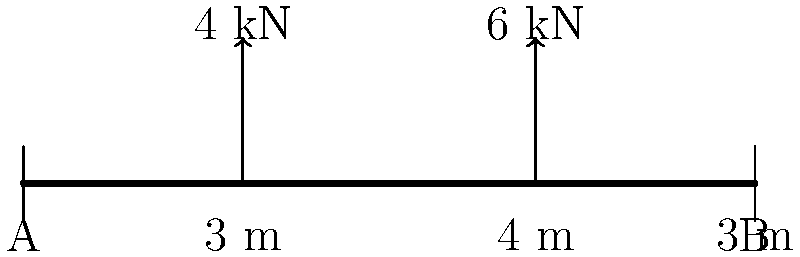As part of a community workshop on ancient structural engineering, you're discussing load distribution on simple beams. Consider a simply supported beam of length 10 m with two concentrated forces: a 4 kN force at 3 m from the left support and a 6 kN force at 7 m from the left support. Calculate the reaction force at support A. To solve this problem, we'll use the principles of static equilibrium. Here's a step-by-step approach:

1) First, let's define our variables:
   $R_A$ = Reaction force at support A
   $R_B$ = Reaction force at support B

2) We know that for a beam in equilibrium, the sum of all vertical forces must equal zero:
   $$\sum F_y = 0$$
   $$R_A + R_B - 4 \text{ kN} - 6 \text{ kN} = 0$$

3) We also know that the sum of moments about any point should be zero. Let's take moments about point A:
   $$\sum M_A = 0$$
   $$(4 \text{ kN} \times 3 \text{ m}) + (6 \text{ kN} \times 7 \text{ m}) - (R_B \times 10 \text{ m}) = 0$$
   $$12 + 42 - 10R_B = 0$$
   $$54 = 10R_B$$
   $$R_B = 5.4 \text{ kN}$$

4) Now that we know $R_B$, we can substitute this back into the equation from step 2:
   $$R_A + 5.4 \text{ kN} - 4 \text{ kN} - 6 \text{ kN} = 0$$
   $$R_A = 4.6 \text{ kN}$$

Therefore, the reaction force at support A is 4.6 kN.
Answer: 4.6 kN 